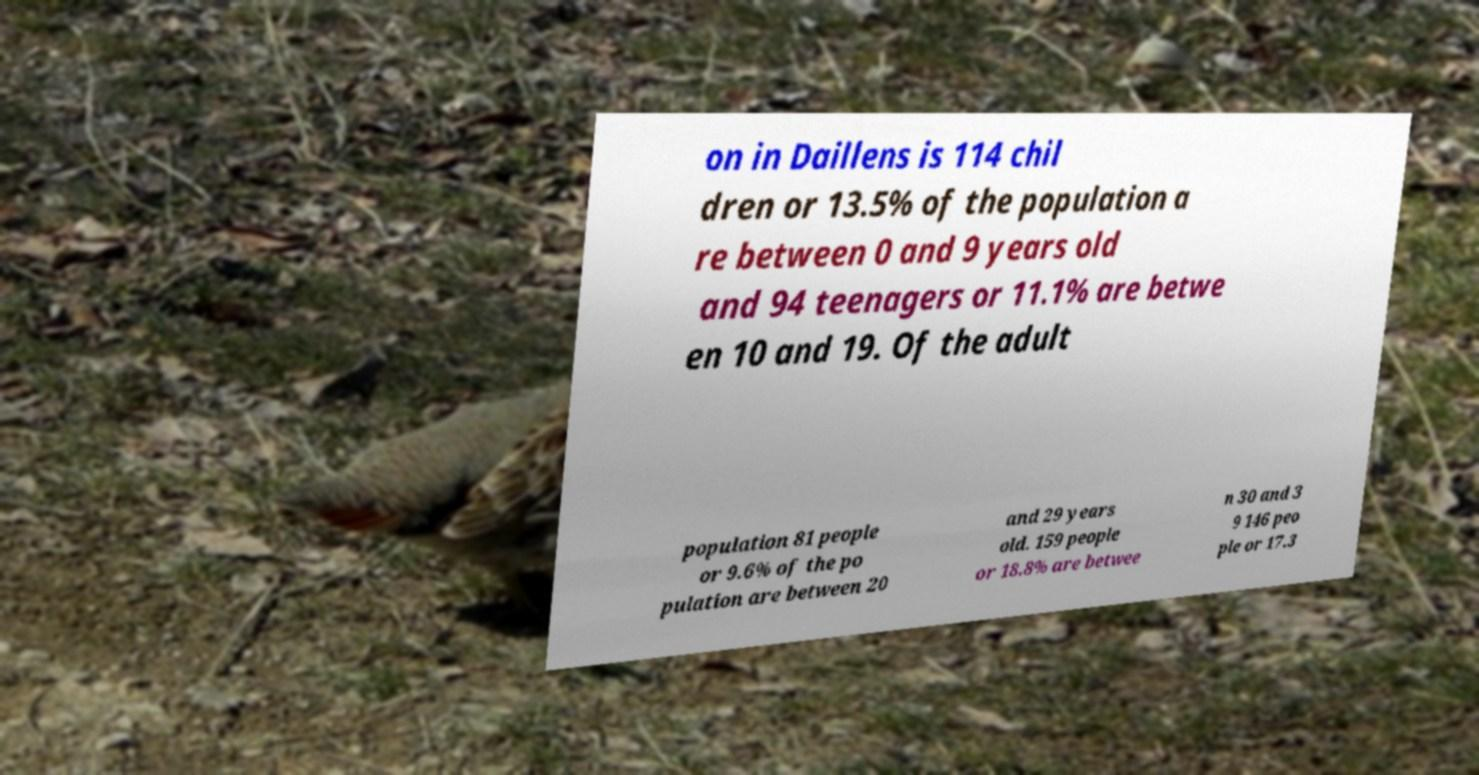There's text embedded in this image that I need extracted. Can you transcribe it verbatim? on in Daillens is 114 chil dren or 13.5% of the population a re between 0 and 9 years old and 94 teenagers or 11.1% are betwe en 10 and 19. Of the adult population 81 people or 9.6% of the po pulation are between 20 and 29 years old. 159 people or 18.8% are betwee n 30 and 3 9 146 peo ple or 17.3 